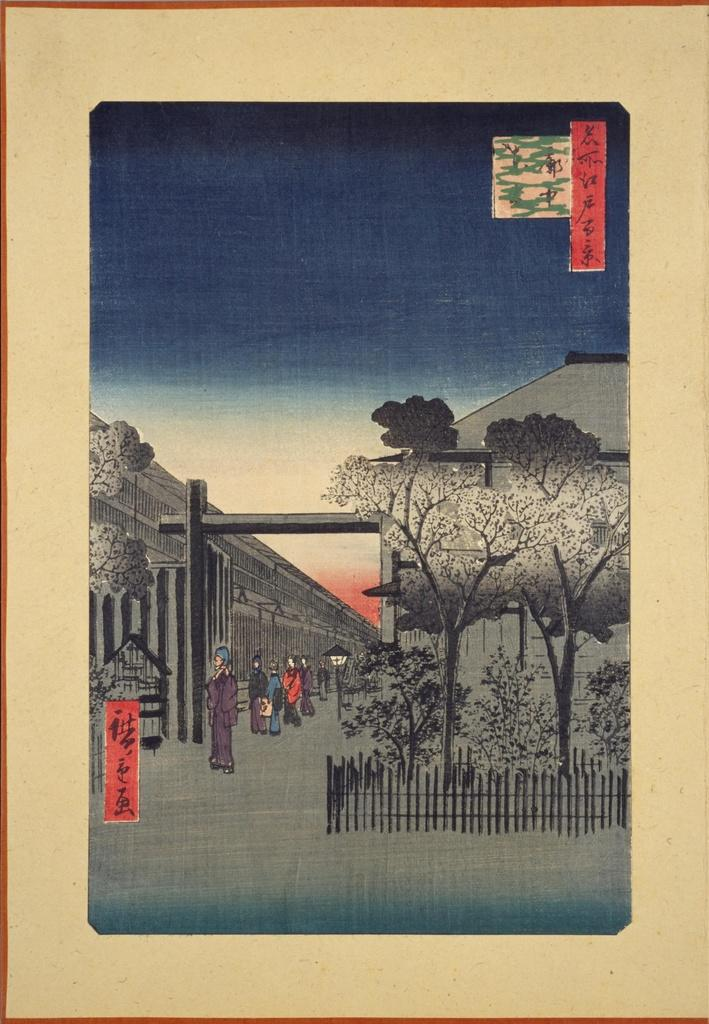What is the main subject of the image? The main subject of the image is a frame with a painting. What elements are depicted in the painting? The painting contains trees, people, buildings, and sky. Is there any text present in the image? Yes, there is text in the image. How many chairs are visible in the painting? There are no chairs depicted in the painting; it contains trees, people, buildings, and sky. Is there a drum featured in the painting? There is no drum present in the painting; it contains trees, people, buildings, and sky. 